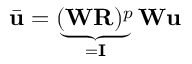Convert formula to latex. <formula><loc_0><loc_0><loc_500><loc_500>\bar { u } = \underbrace { ( W R ) ^ { p } } _ { = I } W u</formula> 